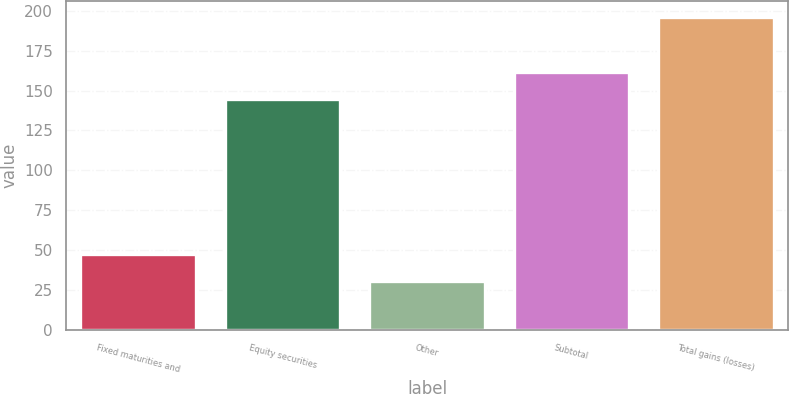Convert chart to OTSL. <chart><loc_0><loc_0><loc_500><loc_500><bar_chart><fcel>Fixed maturities and<fcel>Equity securities<fcel>Other<fcel>Subtotal<fcel>Total gains (losses)<nl><fcel>47.5<fcel>145<fcel>31<fcel>161.5<fcel>196<nl></chart> 